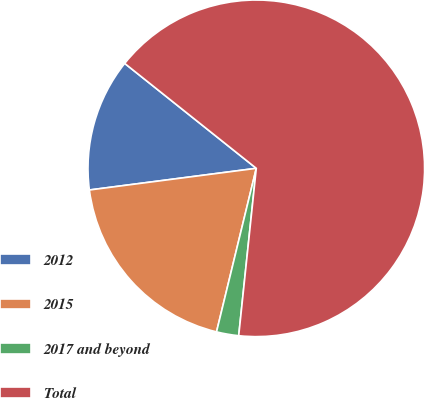Convert chart. <chart><loc_0><loc_0><loc_500><loc_500><pie_chart><fcel>2012<fcel>2015<fcel>2017 and beyond<fcel>Total<nl><fcel>12.77%<fcel>19.15%<fcel>2.13%<fcel>65.96%<nl></chart> 